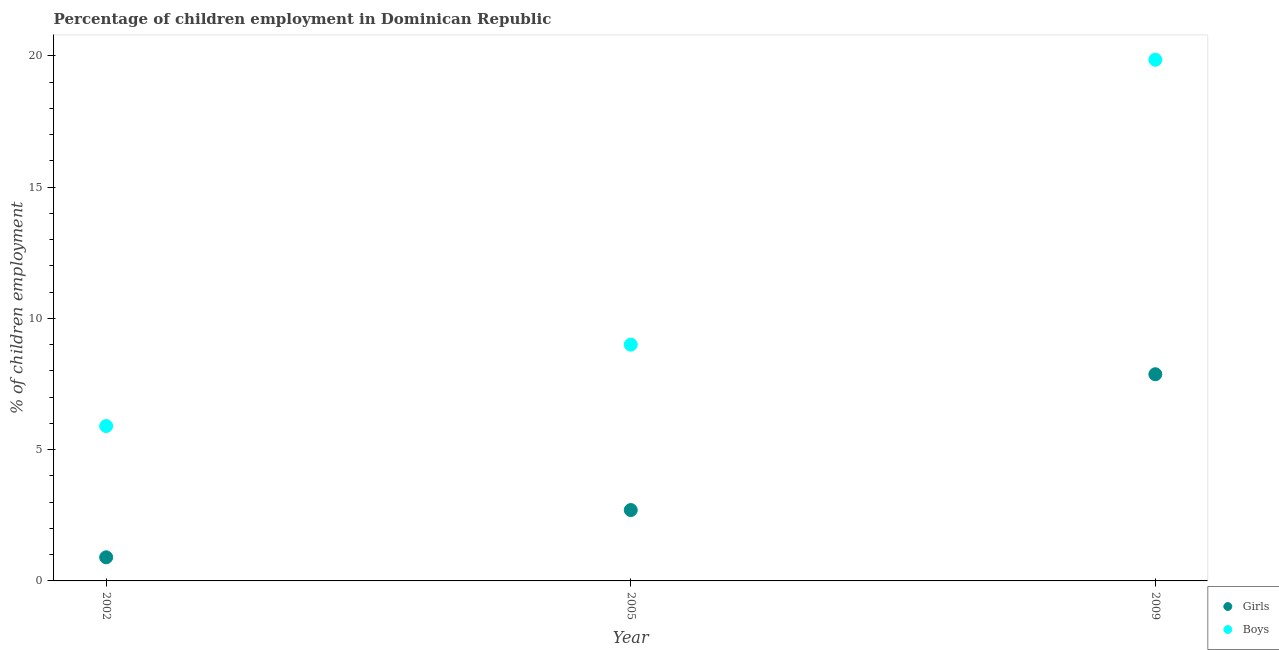Is the number of dotlines equal to the number of legend labels?
Your answer should be very brief. Yes. Across all years, what is the maximum percentage of employed girls?
Ensure brevity in your answer.  7.87. Across all years, what is the minimum percentage of employed girls?
Keep it short and to the point. 0.9. In which year was the percentage of employed boys maximum?
Ensure brevity in your answer.  2009. In which year was the percentage of employed girls minimum?
Your response must be concise. 2002. What is the total percentage of employed boys in the graph?
Your answer should be very brief. 34.75. What is the difference between the percentage of employed boys in 2002 and that in 2009?
Ensure brevity in your answer.  -13.95. What is the difference between the percentage of employed boys in 2009 and the percentage of employed girls in 2005?
Ensure brevity in your answer.  17.15. What is the average percentage of employed boys per year?
Ensure brevity in your answer.  11.58. In how many years, is the percentage of employed girls greater than 14 %?
Offer a terse response. 0. What is the ratio of the percentage of employed boys in 2005 to that in 2009?
Provide a short and direct response. 0.45. Is the percentage of employed boys in 2005 less than that in 2009?
Your answer should be compact. Yes. Is the difference between the percentage of employed boys in 2005 and 2009 greater than the difference between the percentage of employed girls in 2005 and 2009?
Give a very brief answer. No. What is the difference between the highest and the second highest percentage of employed boys?
Ensure brevity in your answer.  10.85. What is the difference between the highest and the lowest percentage of employed boys?
Your response must be concise. 13.95. Does the percentage of employed girls monotonically increase over the years?
Keep it short and to the point. Yes. Is the percentage of employed boys strictly greater than the percentage of employed girls over the years?
Keep it short and to the point. Yes. How many dotlines are there?
Ensure brevity in your answer.  2. How many years are there in the graph?
Your answer should be very brief. 3. What is the difference between two consecutive major ticks on the Y-axis?
Your response must be concise. 5. Are the values on the major ticks of Y-axis written in scientific E-notation?
Provide a short and direct response. No. Does the graph contain any zero values?
Keep it short and to the point. No. Does the graph contain grids?
Give a very brief answer. No. How many legend labels are there?
Offer a terse response. 2. How are the legend labels stacked?
Keep it short and to the point. Vertical. What is the title of the graph?
Offer a terse response. Percentage of children employment in Dominican Republic. What is the label or title of the X-axis?
Your answer should be very brief. Year. What is the label or title of the Y-axis?
Your response must be concise. % of children employment. What is the % of children employment of Girls in 2009?
Provide a succinct answer. 7.87. What is the % of children employment in Boys in 2009?
Make the answer very short. 19.85. Across all years, what is the maximum % of children employment in Girls?
Your answer should be compact. 7.87. Across all years, what is the maximum % of children employment in Boys?
Ensure brevity in your answer.  19.85. Across all years, what is the minimum % of children employment in Boys?
Make the answer very short. 5.9. What is the total % of children employment of Girls in the graph?
Provide a succinct answer. 11.47. What is the total % of children employment of Boys in the graph?
Offer a terse response. 34.75. What is the difference between the % of children employment in Girls in 2002 and that in 2009?
Make the answer very short. -6.97. What is the difference between the % of children employment in Boys in 2002 and that in 2009?
Your answer should be compact. -13.95. What is the difference between the % of children employment in Girls in 2005 and that in 2009?
Your response must be concise. -5.17. What is the difference between the % of children employment of Boys in 2005 and that in 2009?
Keep it short and to the point. -10.85. What is the difference between the % of children employment in Girls in 2002 and the % of children employment in Boys in 2009?
Offer a terse response. -18.95. What is the difference between the % of children employment in Girls in 2005 and the % of children employment in Boys in 2009?
Offer a terse response. -17.15. What is the average % of children employment in Girls per year?
Make the answer very short. 3.82. What is the average % of children employment in Boys per year?
Offer a terse response. 11.58. In the year 2002, what is the difference between the % of children employment in Girls and % of children employment in Boys?
Give a very brief answer. -5. In the year 2009, what is the difference between the % of children employment in Girls and % of children employment in Boys?
Keep it short and to the point. -11.98. What is the ratio of the % of children employment in Boys in 2002 to that in 2005?
Make the answer very short. 0.66. What is the ratio of the % of children employment of Girls in 2002 to that in 2009?
Your answer should be compact. 0.11. What is the ratio of the % of children employment in Boys in 2002 to that in 2009?
Ensure brevity in your answer.  0.3. What is the ratio of the % of children employment of Girls in 2005 to that in 2009?
Offer a very short reply. 0.34. What is the ratio of the % of children employment in Boys in 2005 to that in 2009?
Offer a terse response. 0.45. What is the difference between the highest and the second highest % of children employment in Girls?
Ensure brevity in your answer.  5.17. What is the difference between the highest and the second highest % of children employment in Boys?
Offer a terse response. 10.85. What is the difference between the highest and the lowest % of children employment in Girls?
Your response must be concise. 6.97. What is the difference between the highest and the lowest % of children employment of Boys?
Offer a very short reply. 13.95. 